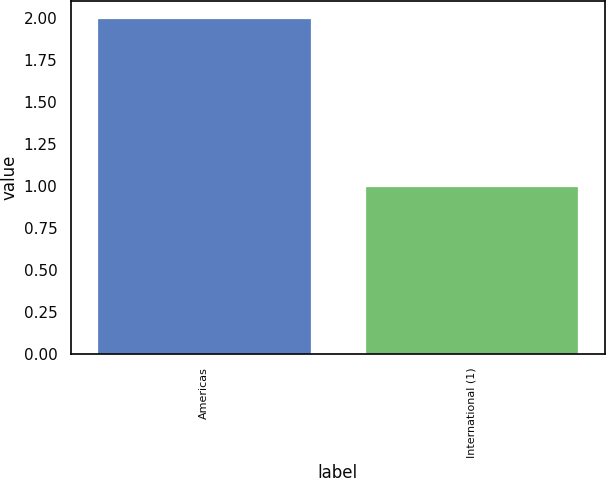Convert chart to OTSL. <chart><loc_0><loc_0><loc_500><loc_500><bar_chart><fcel>Americas<fcel>International (1)<nl><fcel>2<fcel>1<nl></chart> 